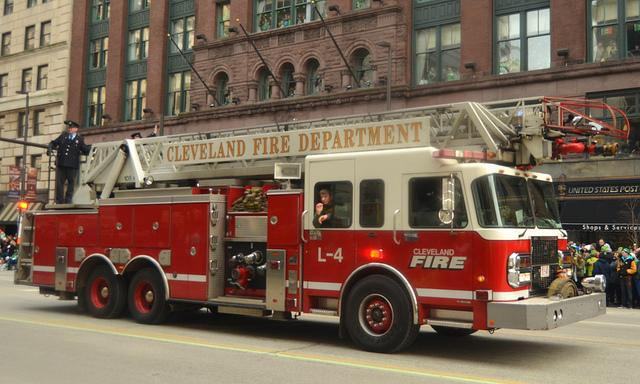What state is this city in?

Choices:
A) illinois
B) new zealand
C) new york
D) ohio ohio 